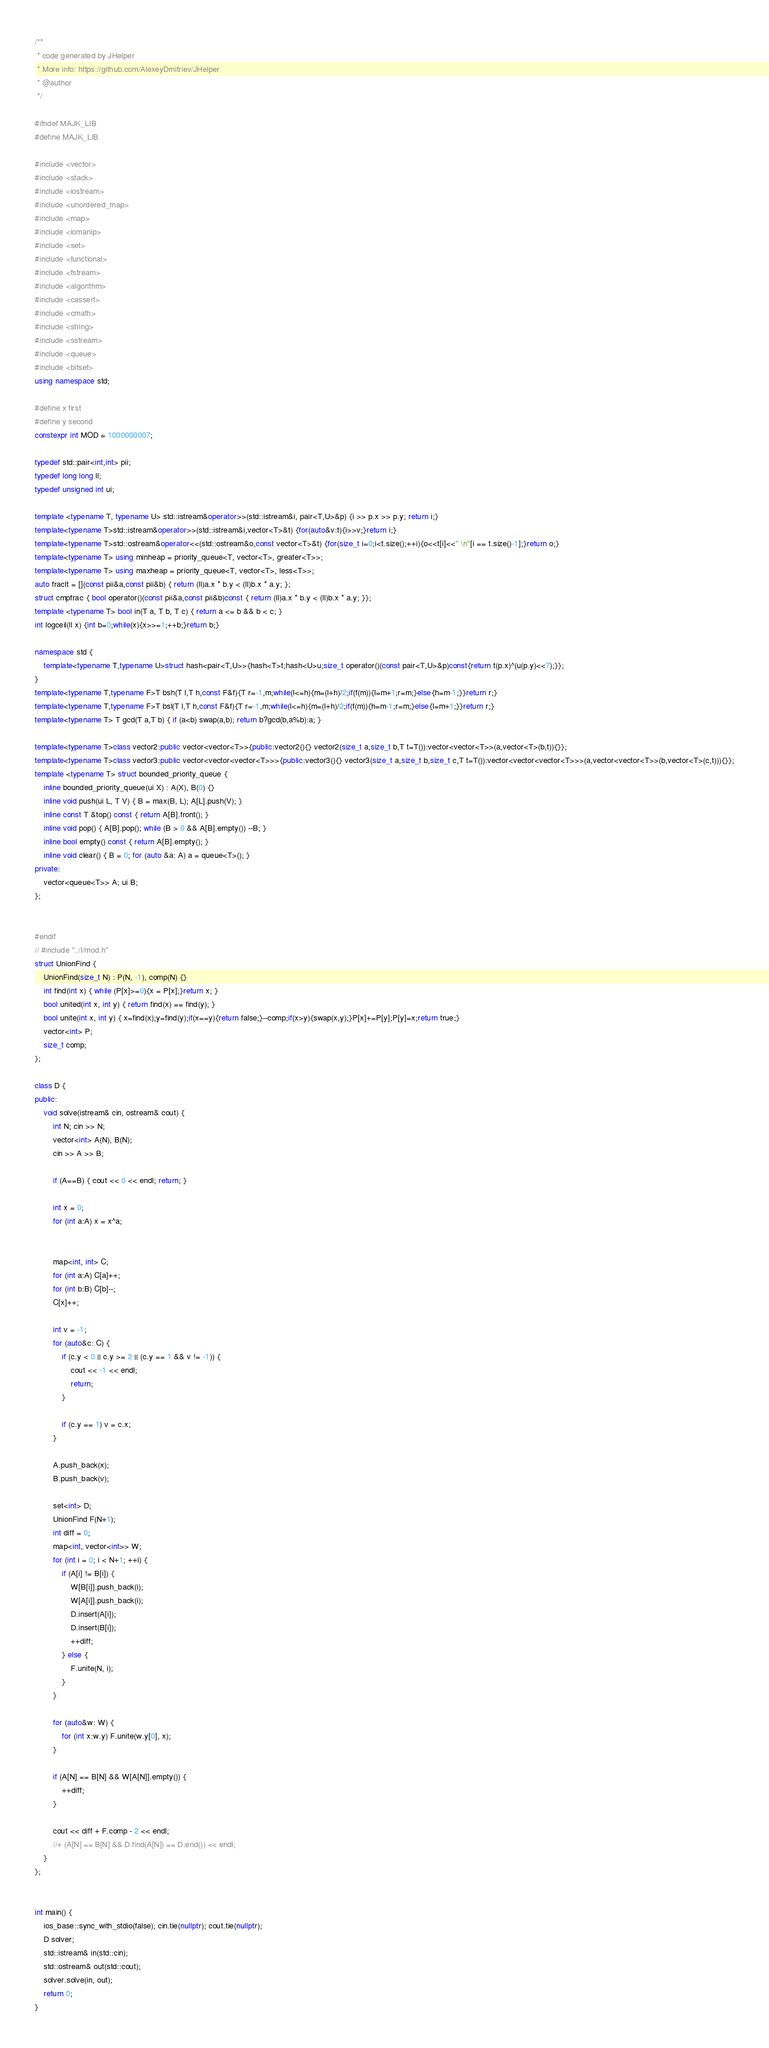<code> <loc_0><loc_0><loc_500><loc_500><_C++_>/**
 * code generated by JHelper
 * More info: https://github.com/AlexeyDmitriev/JHelper
 * @author
 */

#ifndef MAJK_LIB
#define MAJK_LIB

#include <vector>
#include <stack>
#include <iostream>
#include <unordered_map>
#include <map>
#include <iomanip>
#include <set>
#include <functional>
#include <fstream>
#include <algorithm>
#include <cassert>
#include <cmath>
#include <string>
#include <sstream>
#include <queue>
#include <bitset>
using namespace std;

#define x first
#define y second
constexpr int MOD = 1000000007;

typedef std::pair<int,int> pii;
typedef long long ll;
typedef unsigned int ui;

template <typename T, typename U> std::istream&operator>>(std::istream&i, pair<T,U>&p) {i >> p.x >> p.y; return i;}
template<typename T>std::istream&operator>>(std::istream&i,vector<T>&t) {for(auto&v:t){i>>v;}return i;}
template<typename T>std::ostream&operator<<(std::ostream&o,const vector<T>&t) {for(size_t i=0;i<t.size();++i){o<<t[i]<<" \n"[i == t.size()-1];}return o;}
template<typename T> using minheap = priority_queue<T, vector<T>, greater<T>>;
template<typename T> using maxheap = priority_queue<T, vector<T>, less<T>>;
auto fraclt = [](const pii&a,const pii&b) { return (ll)a.x * b.y < (ll)b.x * a.y; };
struct cmpfrac { bool operator()(const pii&a,const pii&b)const { return (ll)a.x * b.y < (ll)b.x * a.y; }};
template <typename T> bool in(T a, T b, T c) { return a <= b && b < c; }
int logceil(ll x) {int b=0;while(x){x>>=1;++b;}return b;}

namespace std {
    template<typename T,typename U>struct hash<pair<T,U>>{hash<T>t;hash<U>u;size_t operator()(const pair<T,U>&p)const{return t(p.x)^(u(p.y)<<7);}};
}
template<typename T,typename F>T bsh(T l,T h,const F&f){T r=-1,m;while(l<=h){m=(l+h)/2;if(f(m)){l=m+1;r=m;}else{h=m-1;}}return r;}
template<typename T,typename F>T bsl(T l,T h,const F&f){T r=-1,m;while(l<=h){m=(l+h)/2;if(f(m)){h=m-1;r=m;}else{l=m+1;}}return r;}
template<typename T> T gcd(T a,T b) { if (a<b) swap(a,b); return b?gcd(b,a%b):a; }

template<typename T>class vector2:public vector<vector<T>>{public:vector2(){} vector2(size_t a,size_t b,T t=T()):vector<vector<T>>(a,vector<T>(b,t)){}};
template<typename T>class vector3:public vector<vector<vector<T>>>{public:vector3(){} vector3(size_t a,size_t b,size_t c,T t=T()):vector<vector<vector<T>>>(a,vector<vector<T>>(b,vector<T>(c,t))){}};
template <typename T> struct bounded_priority_queue {
	inline bounded_priority_queue(ui X) : A(X), B(0) {}
	inline void push(ui L, T V) { B = max(B, L); A[L].push(V); }
	inline const T &top() const { return A[B].front(); }
	inline void pop() { A[B].pop(); while (B > 0 && A[B].empty()) --B; }
	inline bool empty() const { return A[B].empty(); }
	inline void clear() { B = 0; for (auto &a: A) a = queue<T>(); }
private:
	vector<queue<T>> A; ui B;
};


#endif
// #include "../l/mod.h"
struct UnionFind {
	UnionFind(size_t N) : P(N, -1), comp(N) {}
	int find(int x) { while (P[x]>=0){x = P[x];}return x; }
	bool united(int x, int y) { return find(x) == find(y); }
	bool unite(int x, int y) { x=find(x);y=find(y);if(x==y){return false;}--comp;if(x>y){swap(x,y);}P[x]+=P[y];P[y]=x;return true;}
	vector<int> P;
	size_t comp;
};

class D {
public:
    void solve(istream& cin, ostream& cout) {
		int N; cin >> N;
		vector<int> A(N), B(N);
		cin >> A >> B;

		if (A==B) { cout << 0 << endl; return; }

		int x = 0;
		for (int a:A) x = x^a;


		map<int, int> C;
		for (int a:A) C[a]++;
		for (int b:B) C[b]--;
		C[x]++;

		int v = -1;
		for (auto&c: C) {
			if (c.y < 0 || c.y >= 2 || (c.y == 1 && v != -1)) {
				cout << -1 << endl;
				return;
			}

			if (c.y == 1) v = c.x;
		}

		A.push_back(x);
		B.push_back(v);

		set<int> D;
		UnionFind F(N+1);
		int diff = 0;
		map<int, vector<int>> W;
		for (int i = 0; i < N+1; ++i) {
			if (A[i] != B[i]) {
				W[B[i]].push_back(i);
				W[A[i]].push_back(i);
				D.insert(A[i]);
				D.insert(B[i]);
				++diff;
			} else {
				F.unite(N, i);
			}
		}

		for (auto&w: W) {
			for (int x:w.y) F.unite(w.y[0], x);
		}

		if (A[N] == B[N] && W[A[N]].empty()) {
			++diff;
		}

		cout << diff + F.comp - 2 << endl;
		//+ (A[N] == B[N] && D.find(A[N]) == D.end()) << endl;
    }
};


int main() {
	ios_base::sync_with_stdio(false); cin.tie(nullptr); cout.tie(nullptr);
	D solver;
	std::istream& in(std::cin);
	std::ostream& out(std::cout);
	solver.solve(in, out);
	return 0;
}

</code> 